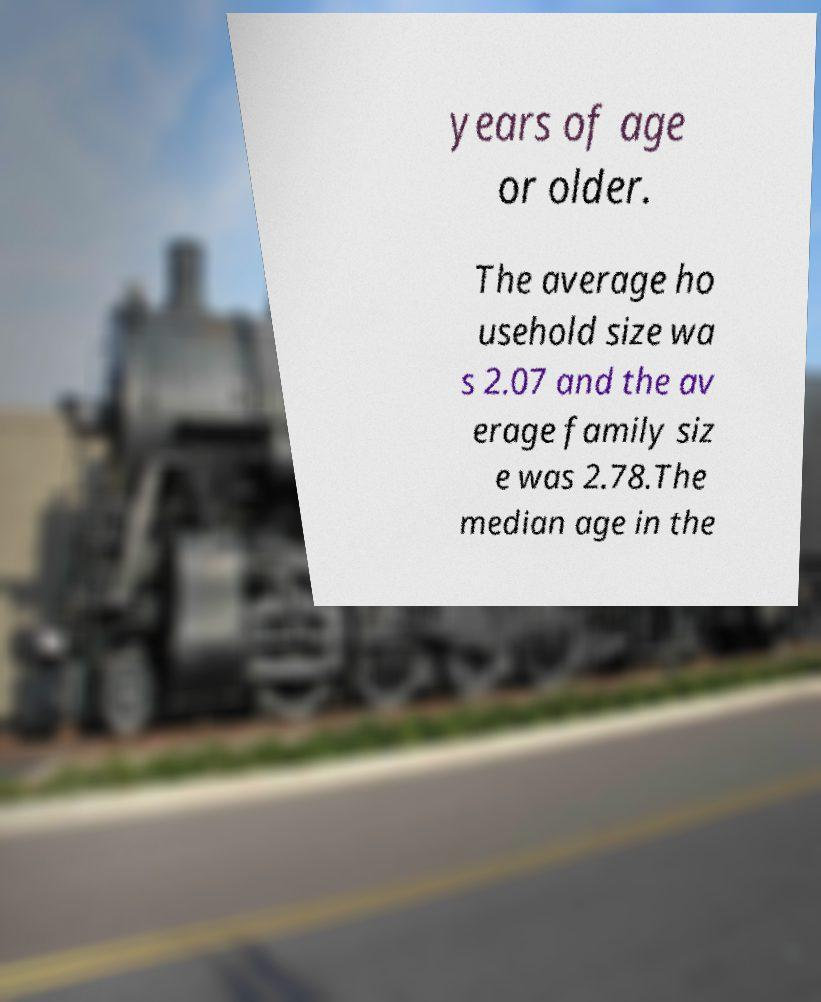What messages or text are displayed in this image? I need them in a readable, typed format. years of age or older. The average ho usehold size wa s 2.07 and the av erage family siz e was 2.78.The median age in the 